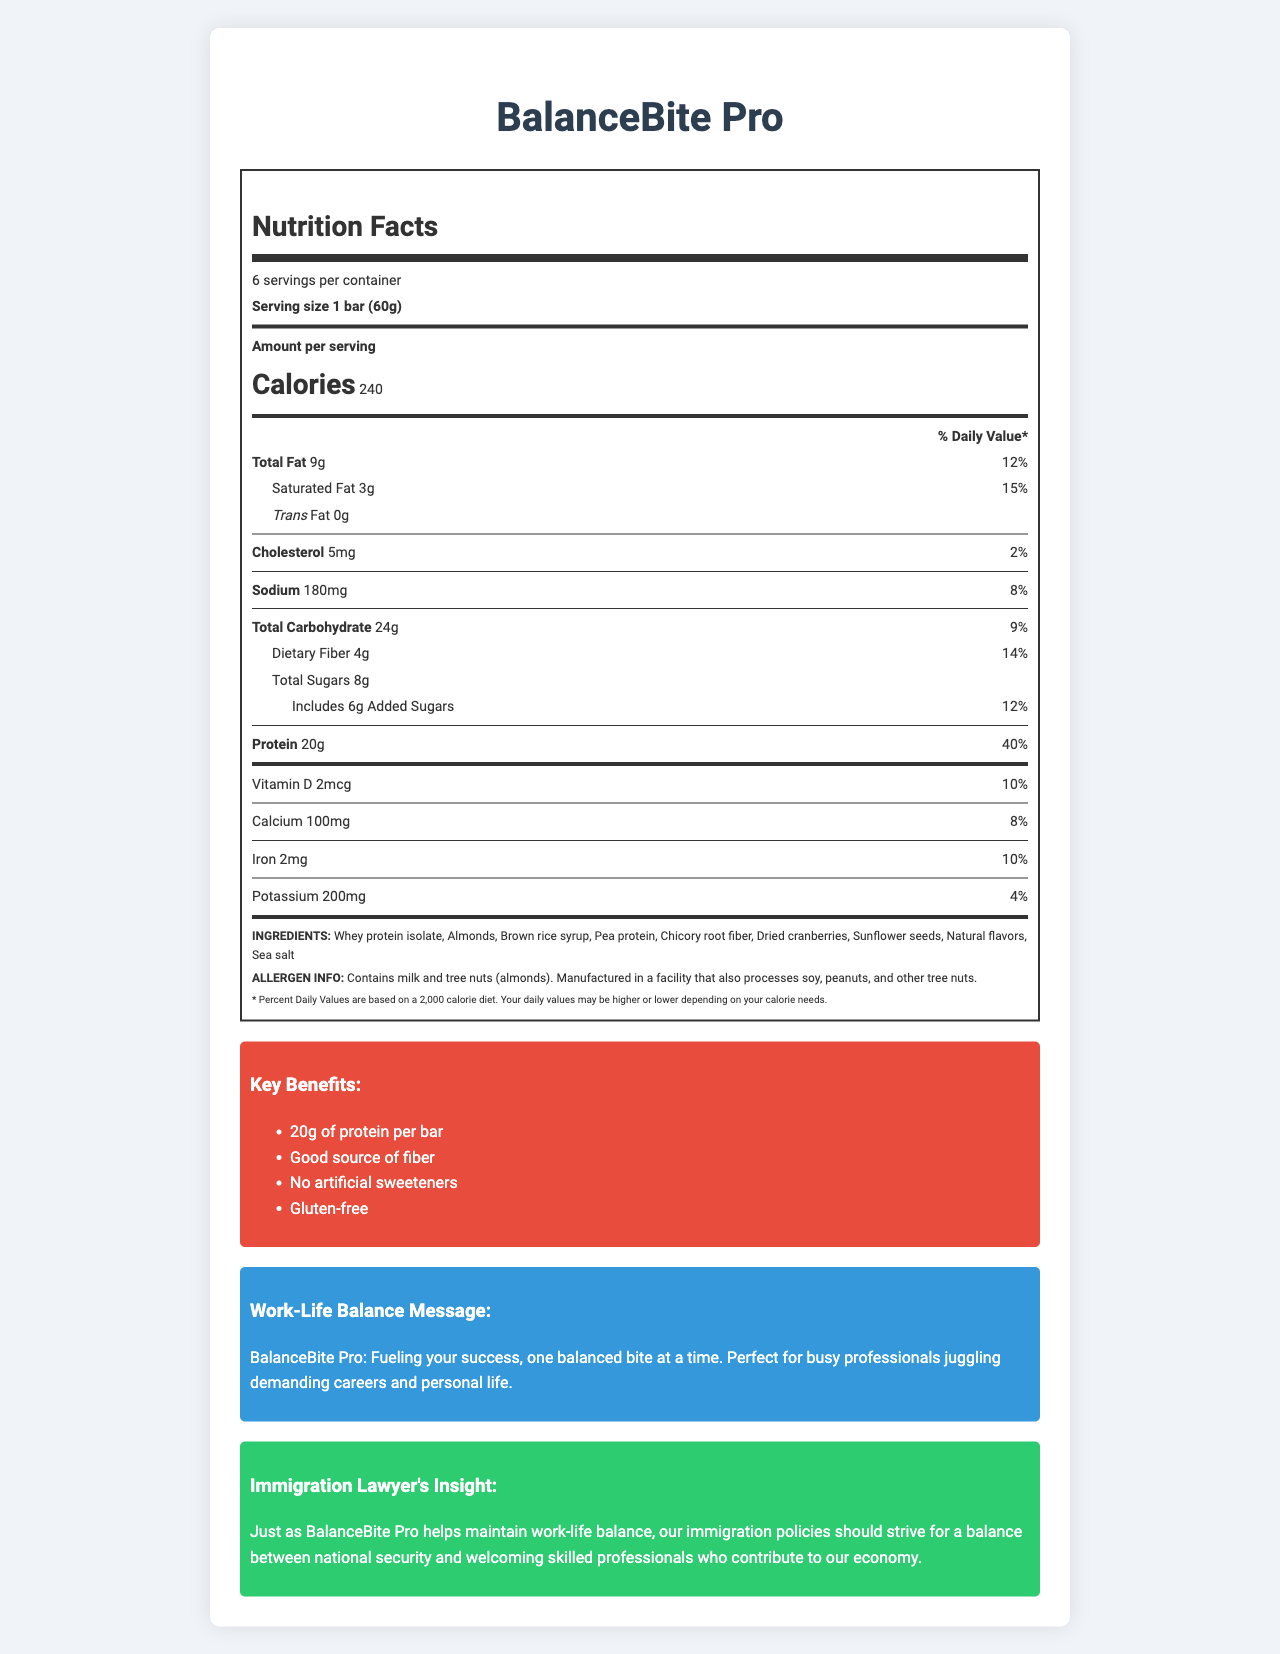who is the target audience for BalanceBite Pro? The document states that BalanceBite Pro is marketed towards busy professionals juggling demanding careers and personal life.
Answer: Busy professionals what is the serving size of BalanceBite Pro? The serving size information is clearly stated in the document as "1 bar (60g)".
Answer: 1 bar (60g) how many servings are there per container? The document mentions that there are 6 servings per container.
Answer: 6 what is the total protein content per bar? The document states that each bar contains 20g of protein.
Answer: 20g what percentage of the Daily Value is provided by the protein in BalanceBite Pro? According to the document, the protein content provides 40% of the Daily Value.
Answer: 40% which ingredient is listed first in the ingredients list? The first ingredient listed is whey protein isolate, which typically indicates it is the most prominent ingredient.
Answer: Whey protein isolate how much saturated fat is there per serving? The saturated fat content per serving is listed as 3g.
Answer: 3g how does the document define the relationship between work-life balance and BalanceBite Pro? The document's work-life balance message highlights that BalanceBite Pro is perfect for busy professionals balancing careers and personal life.
Answer: BalanceBite Pro helps maintain work-life balance by providing a nutritious snack for busy professionals. which statement is true about added sugars in BalanceBite Pro?
A. There are 8g of added sugars.
B. There are 6g of added sugars.
C. There are 4g of added sugars. The document specifies that there are 6g of added sugars per serving.
Answer: B which of the following marketing claims is NOT made about BalanceBite Pro?
I. 20g of protein per bar
II. Low sodium content
III. Gluten-free
IV. Good source of fiber The document does not claim low sodium content among the provided marketing claims.
Answer: II does BalanceBite Pro contain any artificial sweeteners? The document specifically lists "No artificial sweeteners" as one of the marketing claims.
Answer: No do you need to be concerned about tree nuts if you have a nut allergy and want to consume BalanceBite Pro? The allergen information states that the product contains tree nuts (almonds).
Answer: Yes summarize the key nutritional characteristics and benefits of BalanceBite Pro. This summary captures the core nutritional values, marketing claims, and the target audience message from the document.
Answer: BalanceBite Pro is a high-protein snack bar tailored for busy professionals. Each bar (60g) provides 240 calories, 20g of protein (40% DV), 9g of fat (12% DV) including 3g saturated fat (15% DV), and 24g of carbohydrates (9% DV) with 4g of dietary fiber (14% DV). The product is gluten-free, contains no artificial sweeteners, and is a good source of fiber. It is designed for professionals balancing their demanding careers and personal life. what is the exact amount of sea salt in BalanceBite Pro? The document lists sea salt as an ingredient, but it does not provide the exact amount.
Answer: Not enough information 